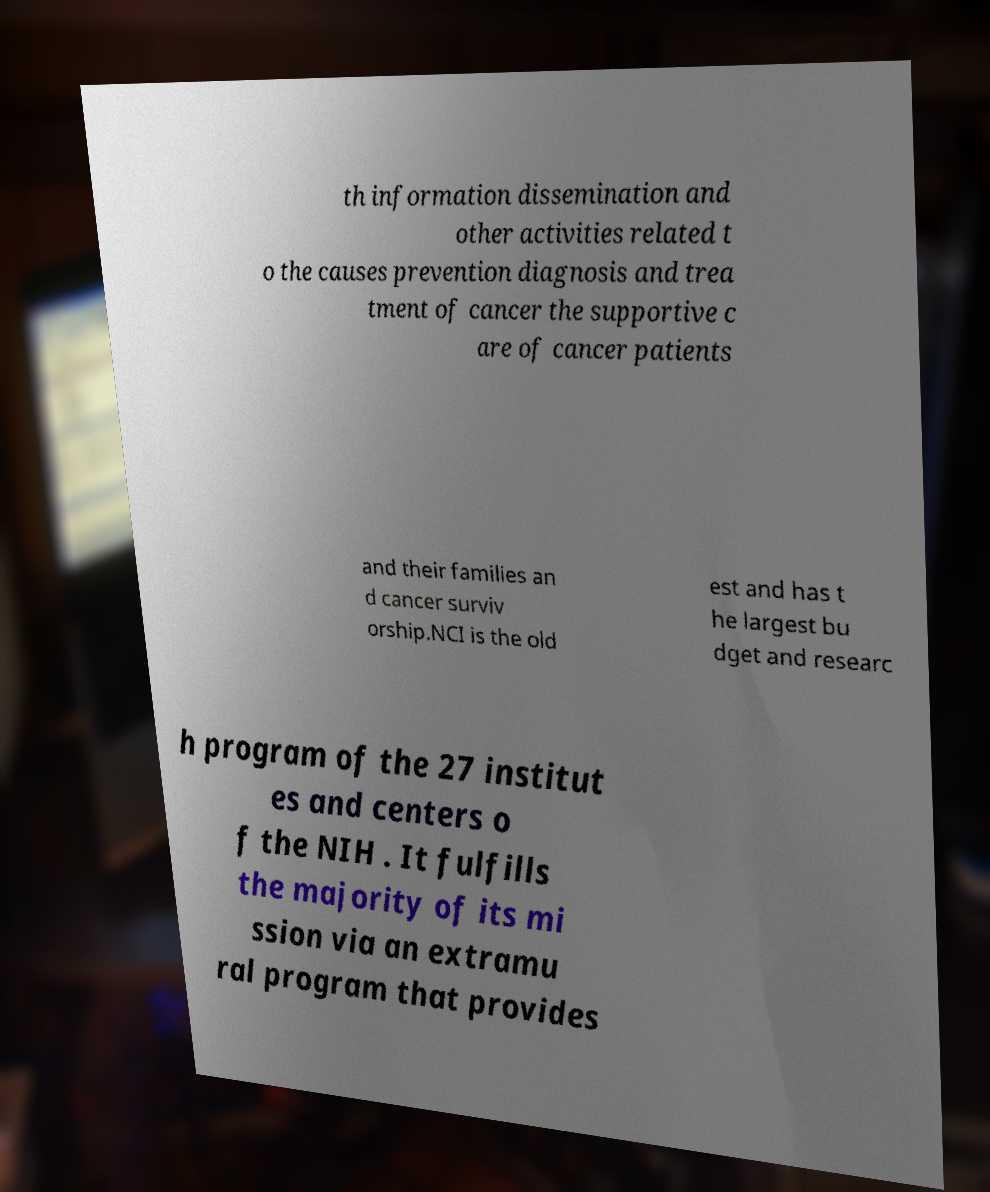For documentation purposes, I need the text within this image transcribed. Could you provide that? th information dissemination and other activities related t o the causes prevention diagnosis and trea tment of cancer the supportive c are of cancer patients and their families an d cancer surviv orship.NCI is the old est and has t he largest bu dget and researc h program of the 27 institut es and centers o f the NIH . It fulfills the majority of its mi ssion via an extramu ral program that provides 